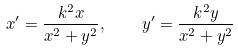<formula> <loc_0><loc_0><loc_500><loc_500>x ^ { \prime } = { \frac { k ^ { 2 } x } { x ^ { 2 } + y ^ { 2 } } } , \quad y ^ { \prime } = { \frac { k ^ { 2 } y } { x ^ { 2 } + y ^ { 2 } } }</formula> 